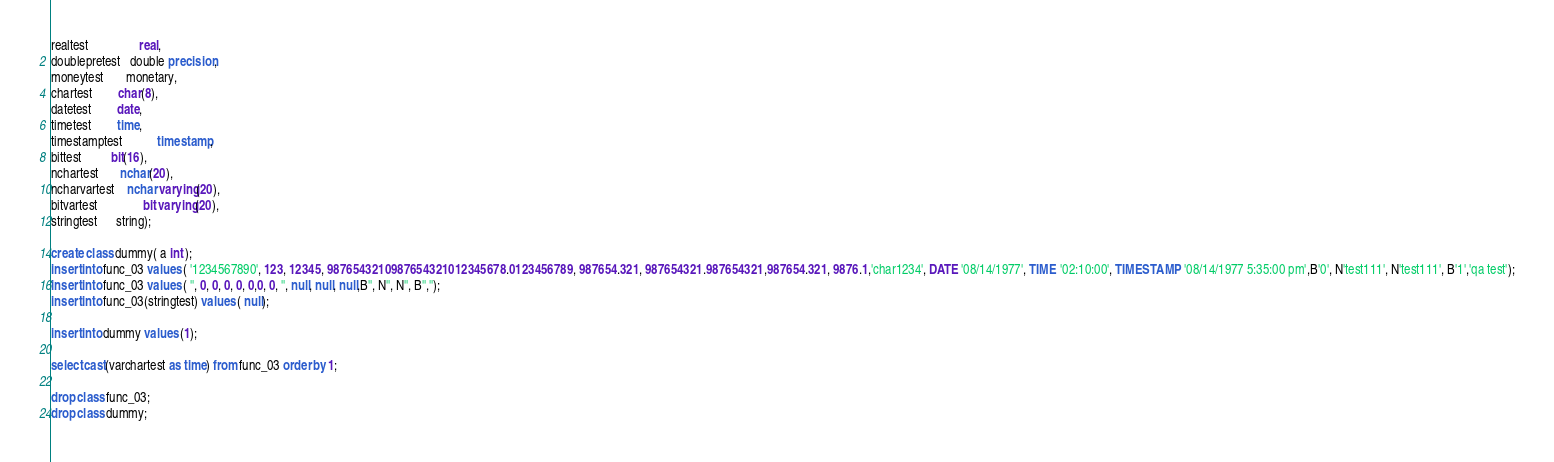Convert code to text. <code><loc_0><loc_0><loc_500><loc_500><_SQL_>realtest                real,
doublepretest   double precision,
moneytest       monetary,
chartest        char(8),
datetest        date,
timetest        time,
timestamptest           timestamp,
bittest         bit(16),
nchartest       nchar(20),
ncharvartest    nchar varying(20),
bitvartest              bit varying(20),
stringtest      string);

create class dummy( a int );
insert into func_03 values ( '1234567890', 123, 12345, 9876543210987654321012345678.0123456789, 987654.321, 987654321.987654321,987654.321, 9876.1,'char1234', DATE '08/14/1977', TIME '02:10:00', TIMESTAMP '08/14/1977 5:35:00 pm',B'0', N'test111', N'test111', B'1','qa test');
insert into func_03 values ( '', 0, 0, 0, 0, 0,0, 0, '', null, null, null,B'', N'', N'', B'','');
insert into func_03(stringtest) values ( null);

insert into dummy values (1);

select cast(varchartest as time) from func_03 order by 1;

drop class func_03;
drop class dummy;
</code> 